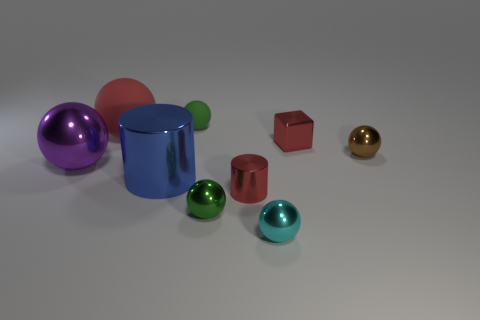Subtract 1 balls. How many balls are left? 5 Subtract all red matte spheres. How many spheres are left? 5 Subtract all green spheres. How many spheres are left? 4 Subtract all yellow spheres. Subtract all brown cylinders. How many spheres are left? 6 Add 1 tiny red cylinders. How many objects exist? 10 Subtract all spheres. How many objects are left? 3 Add 5 large matte balls. How many large matte balls exist? 6 Subtract 1 cyan spheres. How many objects are left? 8 Subtract all cyan metallic things. Subtract all small cyan spheres. How many objects are left? 7 Add 5 tiny green shiny spheres. How many tiny green shiny spheres are left? 6 